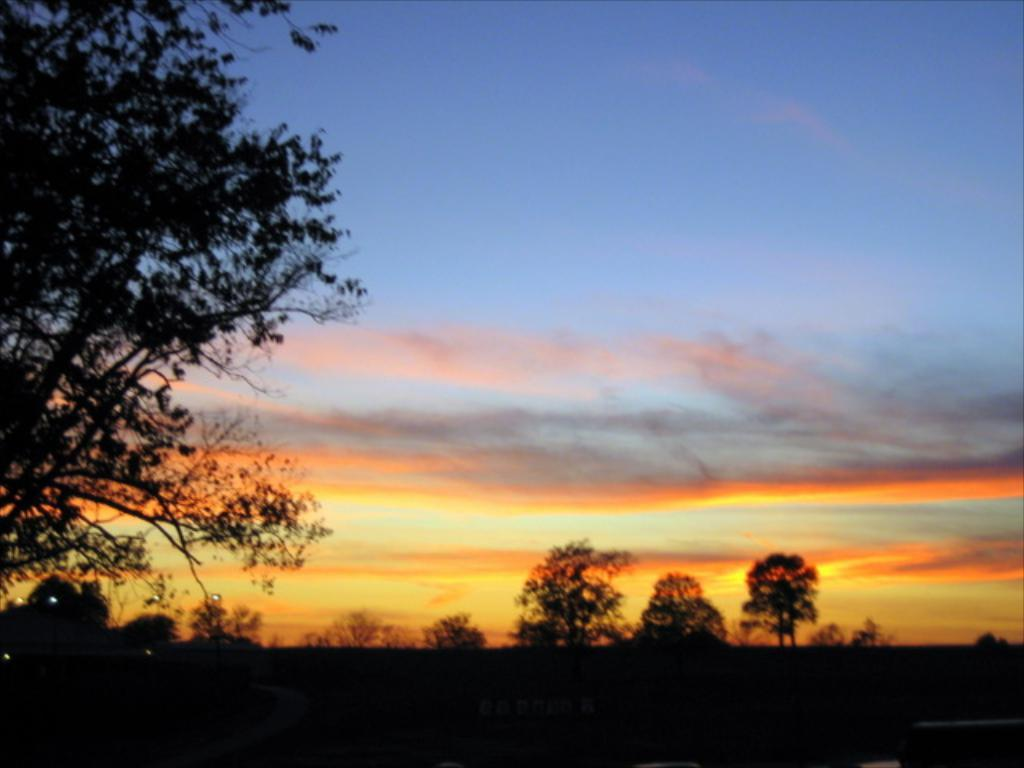What type of vegetation is visible in the foreground of the image? There are trees in the foreground of the image. What can be seen in the background of the image? The background of the image is the sky. What type of music is being played by the pet in the image? There is no pet or music present in the image. What is the pet's name in the image? There is no pet present in the image, so it does not have a name. 